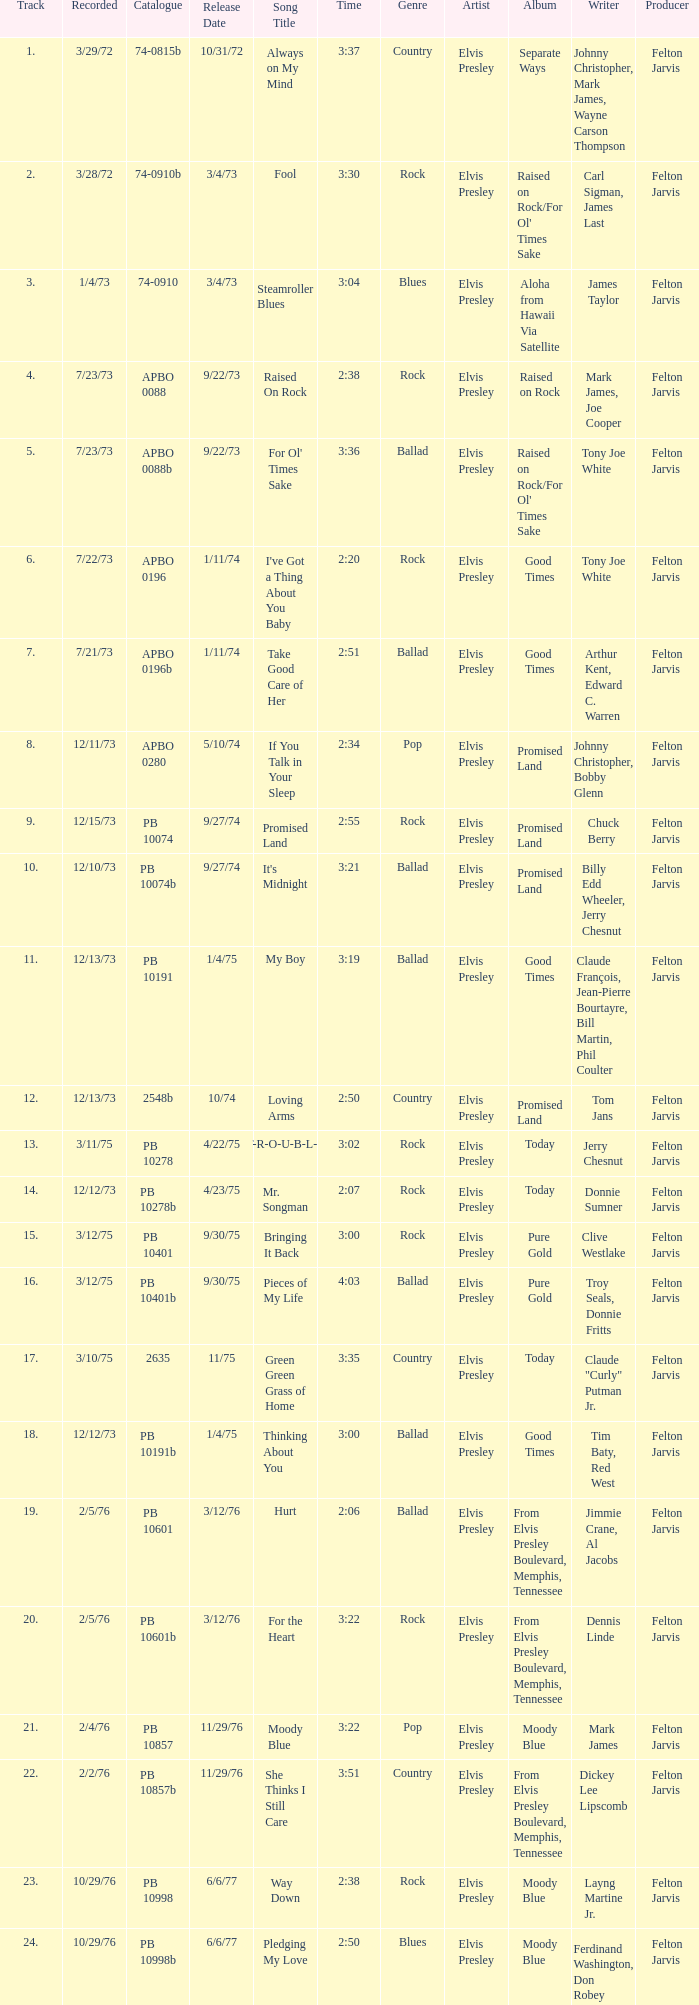Tell me the recorded for time of 2:50 and released date of 6/6/77 with track more than 20 10/29/76. 